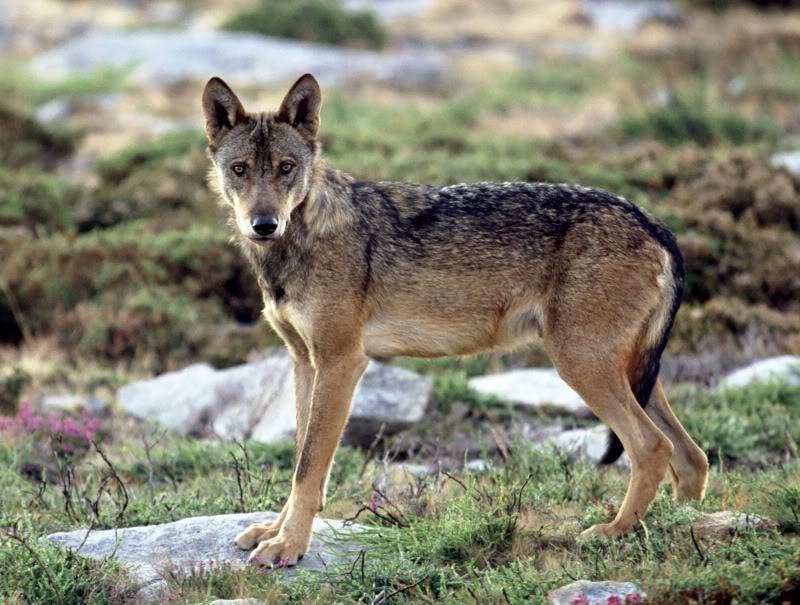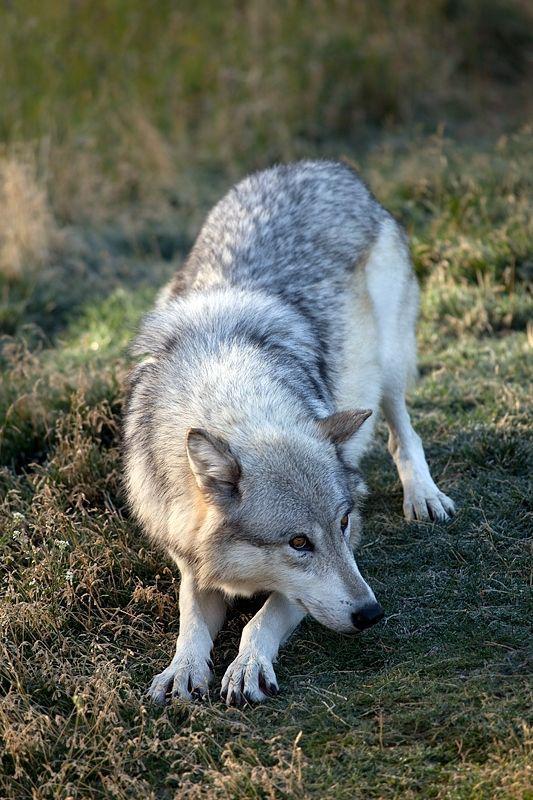The first image is the image on the left, the second image is the image on the right. Examine the images to the left and right. Is the description "One image contains exactly three wolves posed in a row with their bodies angled forward." accurate? Answer yes or no. No. The first image is the image on the left, the second image is the image on the right. Examine the images to the left and right. Is the description "There are only two wolves." accurate? Answer yes or no. Yes. 